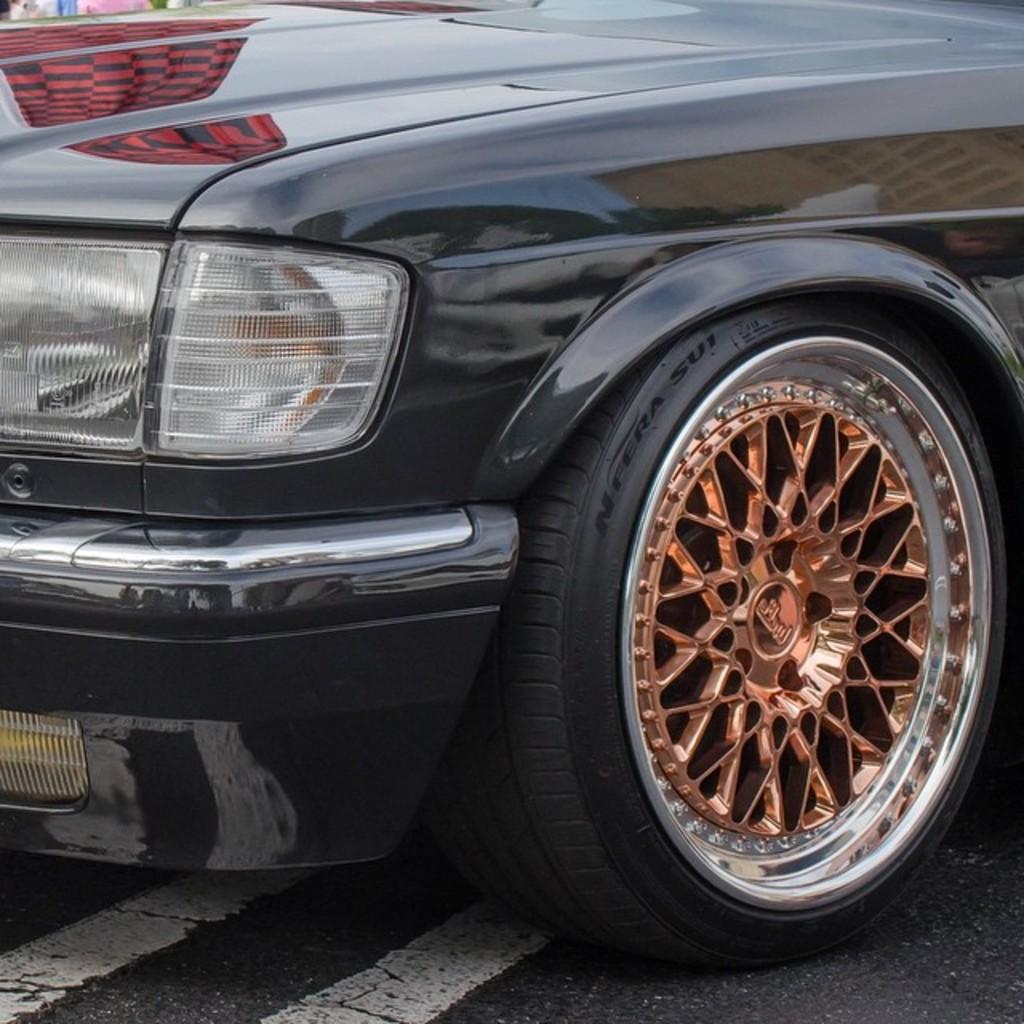What is the main subject in the center of the image? There is a car in the center of the image. What is located at the bottom of the image? There is a road at the bottom of the image. Where is the throne located in the image? There is no throne present in the image. What type of railway can be seen in the image? There is no railway present in the image. 